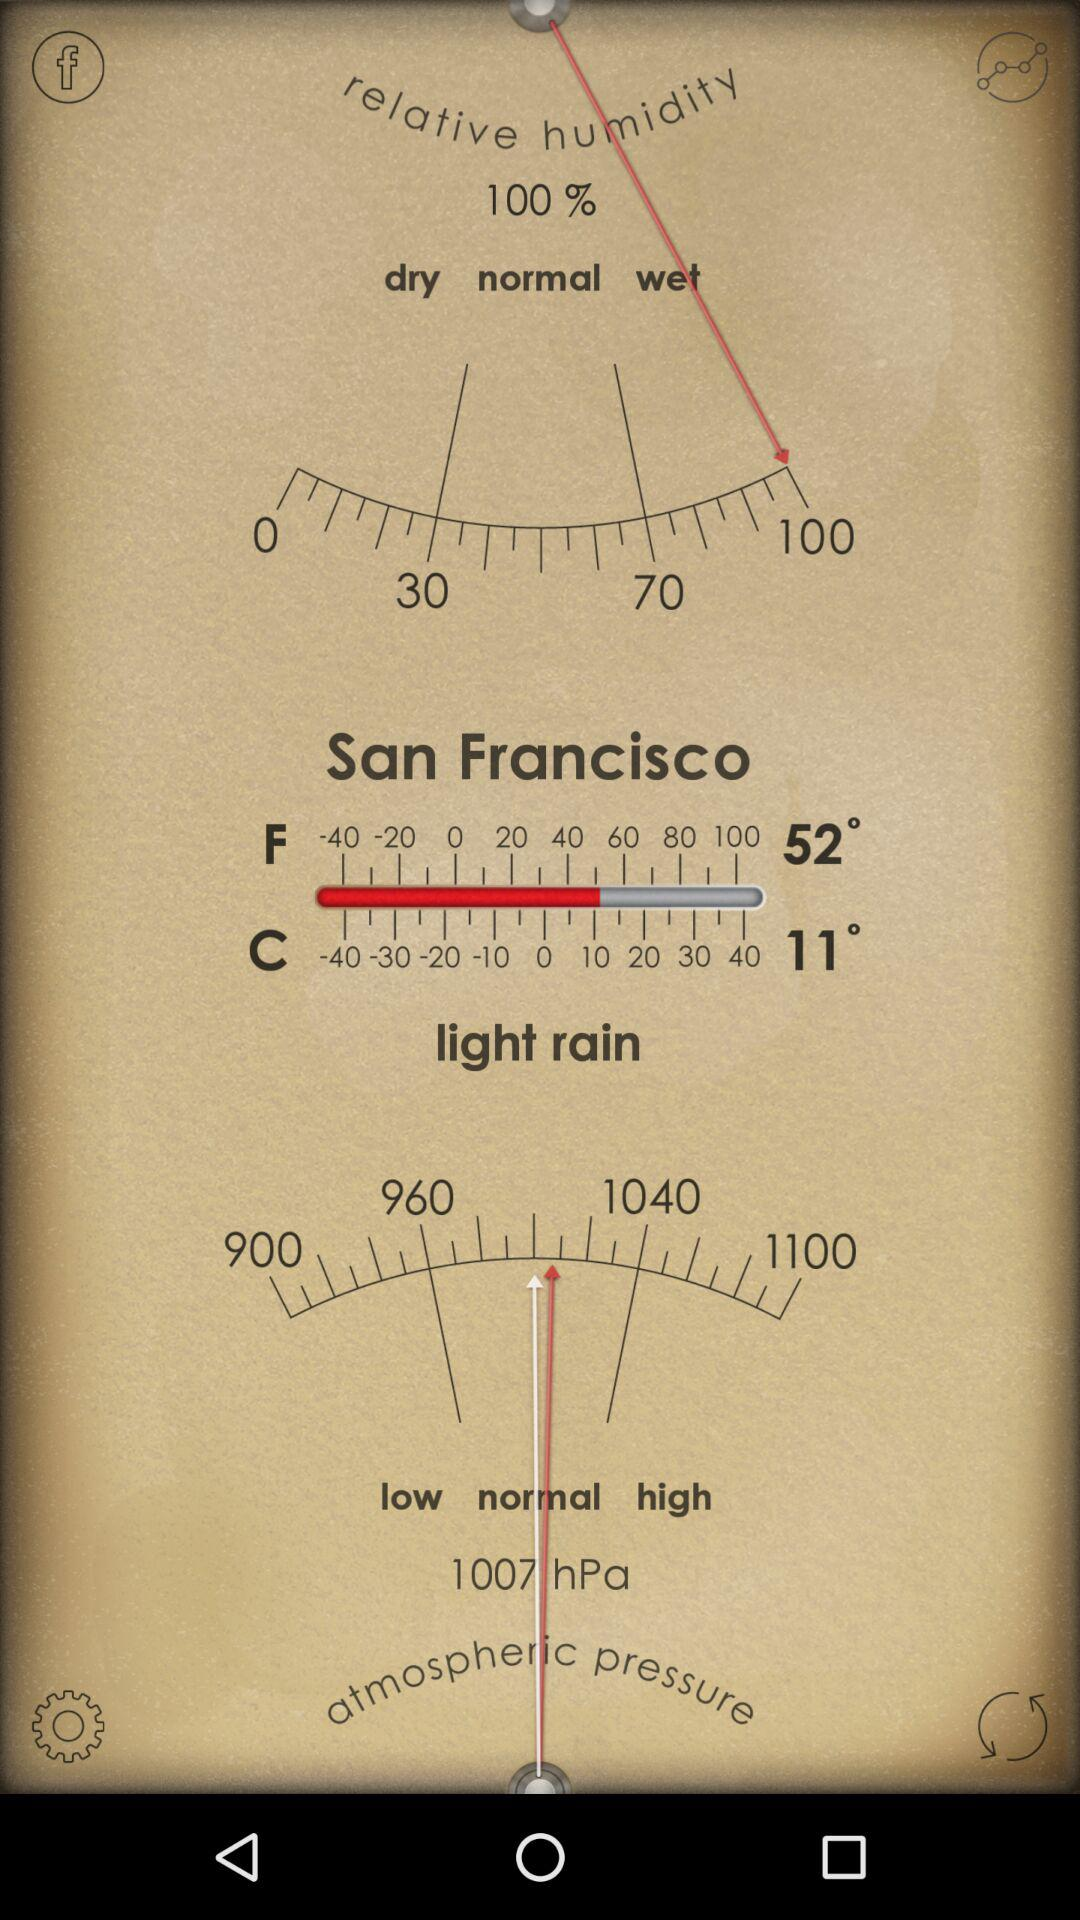What is the highest relative humidity percentage?
Answer the question using a single word or phrase. 100% 